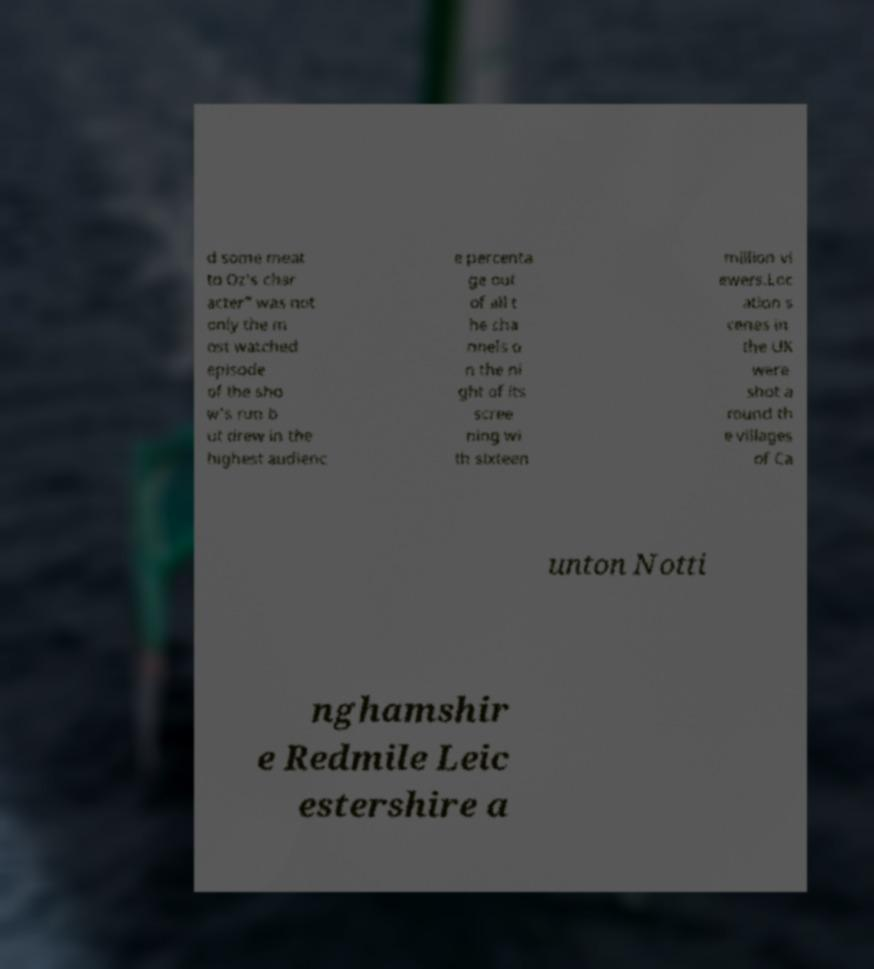Can you accurately transcribe the text from the provided image for me? d some meat to Oz's char acter" was not only the m ost watched episode of the sho w's run b ut drew in the highest audienc e percenta ge out of all t he cha nnels o n the ni ght of its scree ning wi th sixteen million vi ewers.Loc ation s cenes in the UK were shot a round th e villages of Ca unton Notti nghamshir e Redmile Leic estershire a 